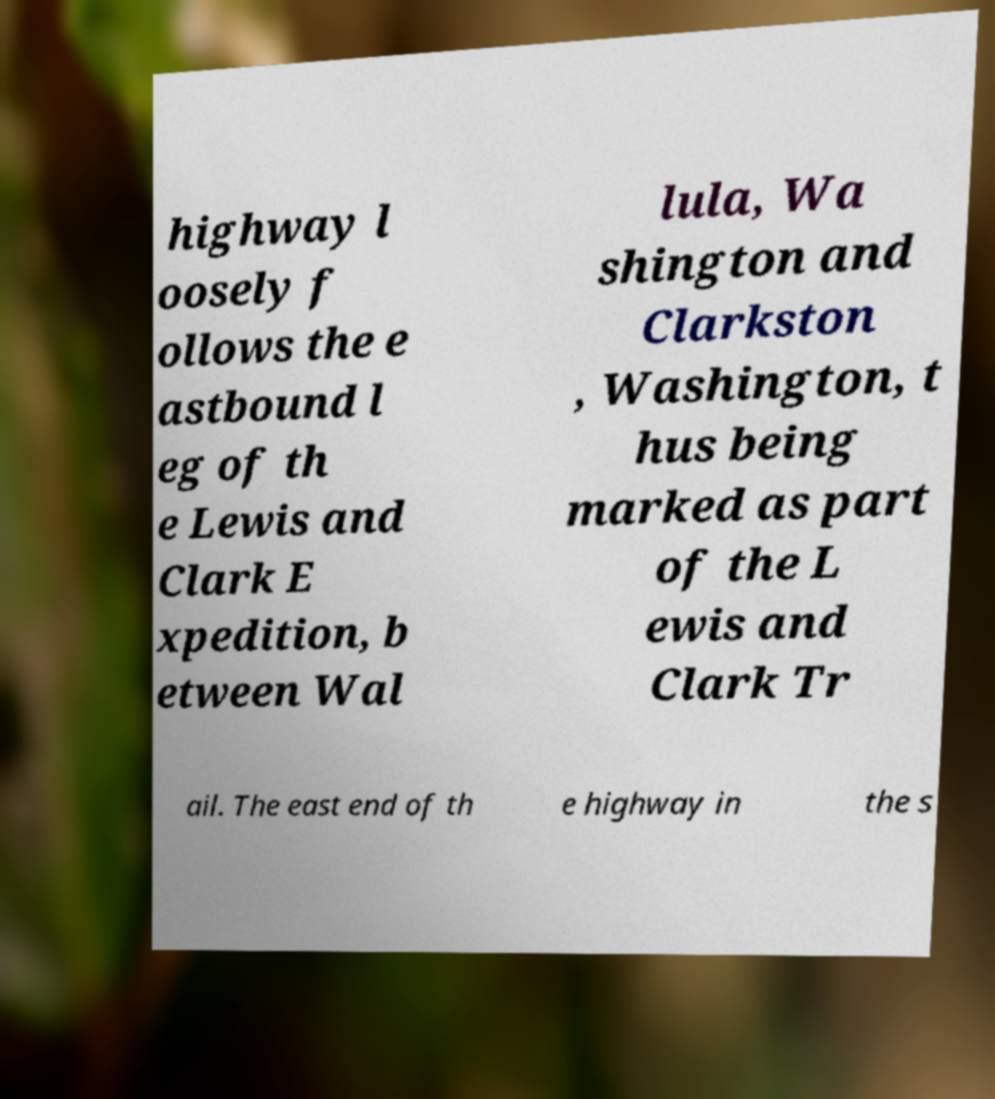What messages or text are displayed in this image? I need them in a readable, typed format. highway l oosely f ollows the e astbound l eg of th e Lewis and Clark E xpedition, b etween Wal lula, Wa shington and Clarkston , Washington, t hus being marked as part of the L ewis and Clark Tr ail. The east end of th e highway in the s 